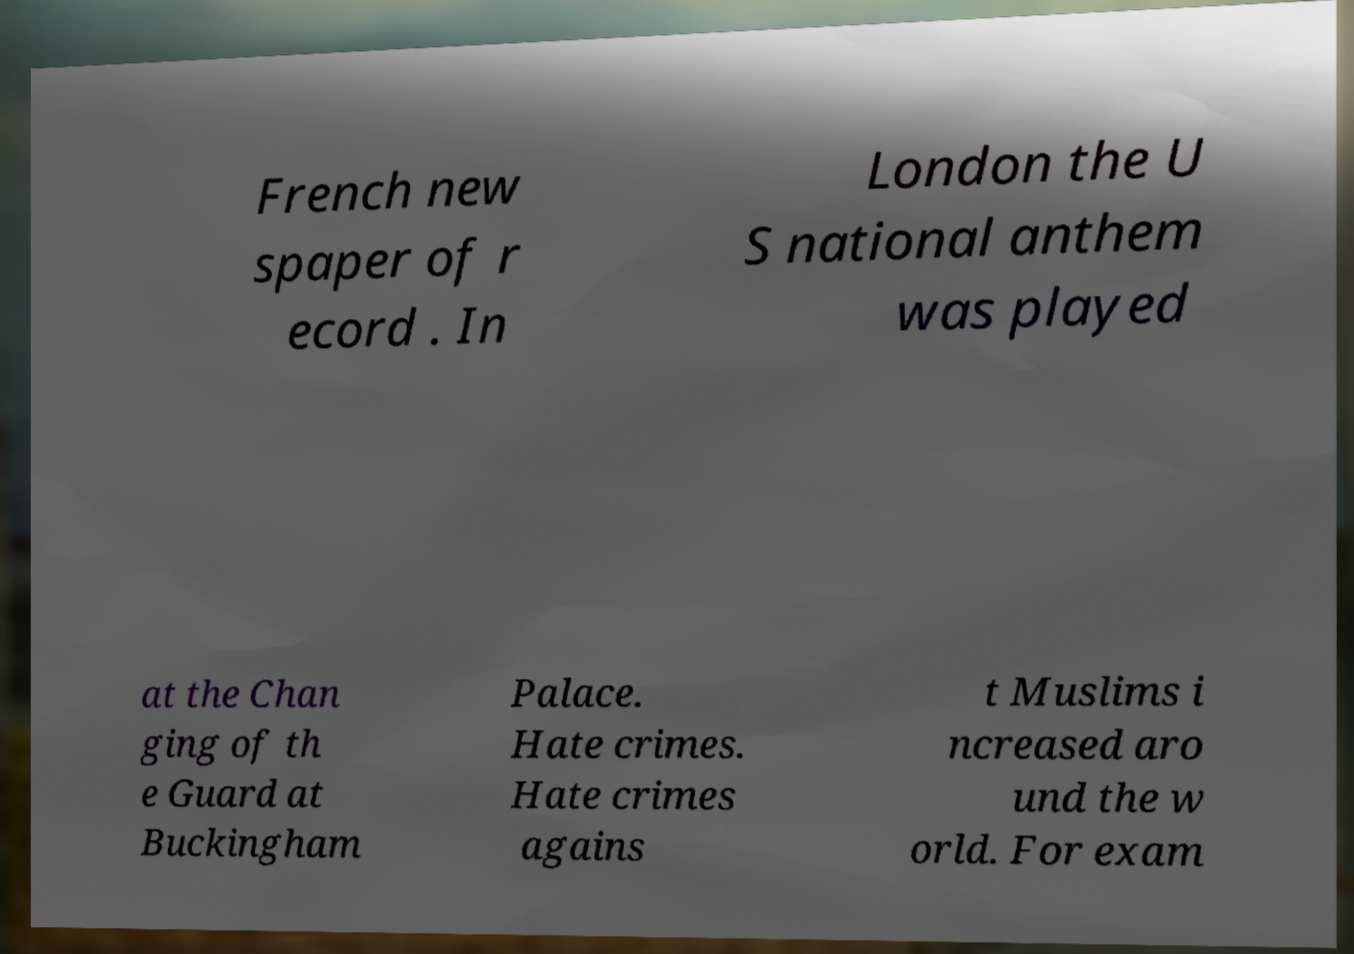There's text embedded in this image that I need extracted. Can you transcribe it verbatim? French new spaper of r ecord . In London the U S national anthem was played at the Chan ging of th e Guard at Buckingham Palace. Hate crimes. Hate crimes agains t Muslims i ncreased aro und the w orld. For exam 